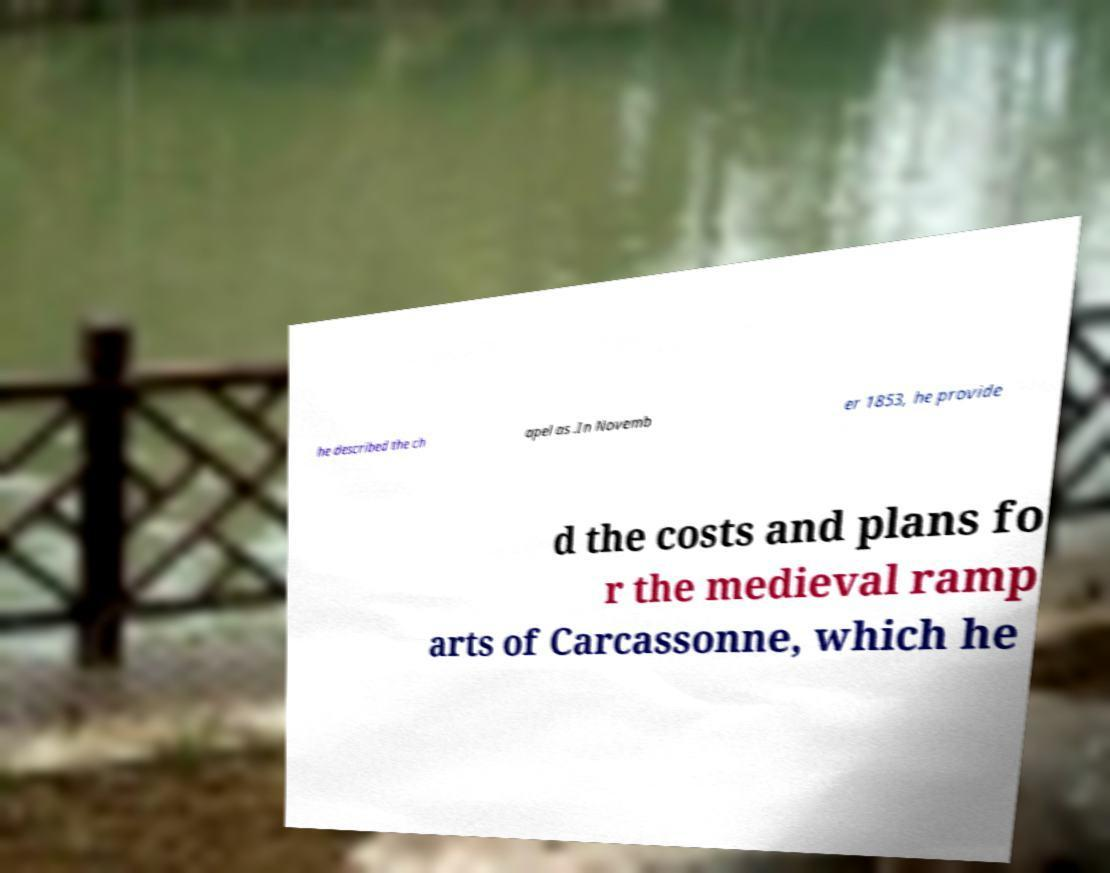For documentation purposes, I need the text within this image transcribed. Could you provide that? he described the ch apel as .In Novemb er 1853, he provide d the costs and plans fo r the medieval ramp arts of Carcassonne, which he 